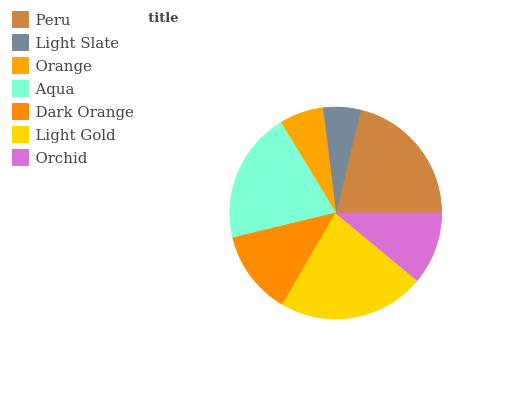Is Light Slate the minimum?
Answer yes or no. Yes. Is Light Gold the maximum?
Answer yes or no. Yes. Is Orange the minimum?
Answer yes or no. No. Is Orange the maximum?
Answer yes or no. No. Is Orange greater than Light Slate?
Answer yes or no. Yes. Is Light Slate less than Orange?
Answer yes or no. Yes. Is Light Slate greater than Orange?
Answer yes or no. No. Is Orange less than Light Slate?
Answer yes or no. No. Is Dark Orange the high median?
Answer yes or no. Yes. Is Dark Orange the low median?
Answer yes or no. Yes. Is Orange the high median?
Answer yes or no. No. Is Peru the low median?
Answer yes or no. No. 